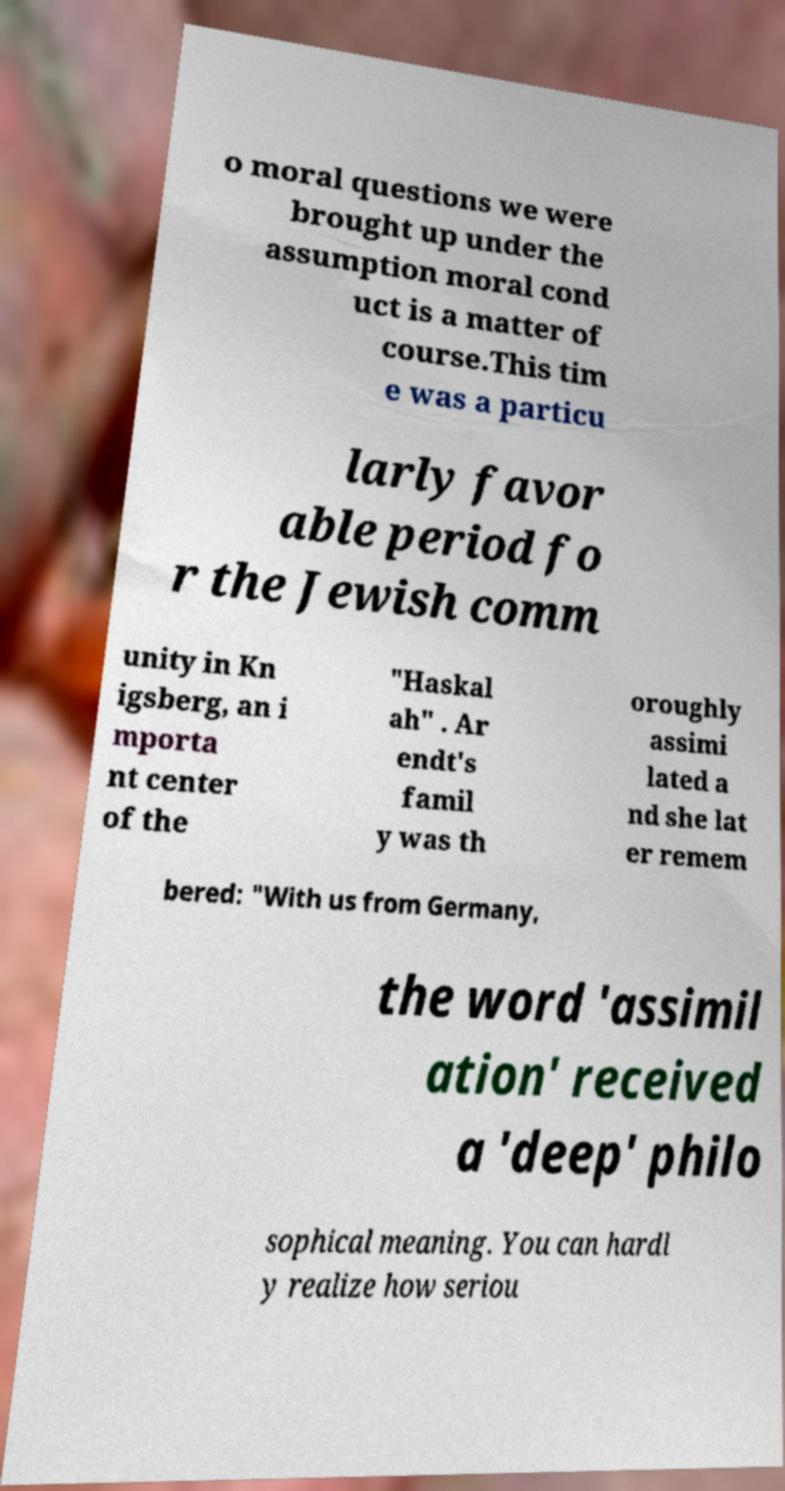Could you assist in decoding the text presented in this image and type it out clearly? o moral questions we were brought up under the assumption moral cond uct is a matter of course.This tim e was a particu larly favor able period fo r the Jewish comm unity in Kn igsberg, an i mporta nt center of the "Haskal ah" . Ar endt's famil y was th oroughly assimi lated a nd she lat er remem bered: "With us from Germany, the word 'assimil ation' received a 'deep' philo sophical meaning. You can hardl y realize how seriou 